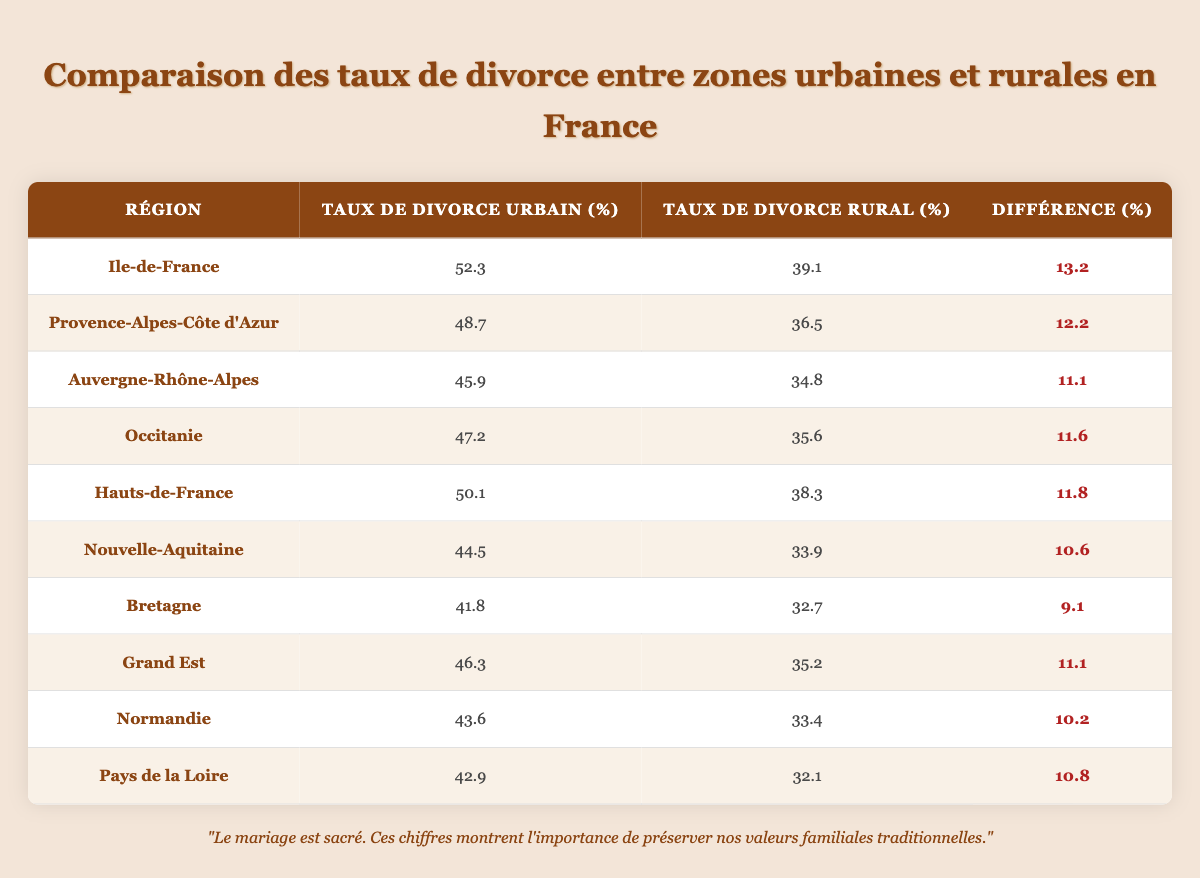What is the urban divorce rate in Ile-de-France? The table lists the urban divorce rate for Ile-de-France as 52.3%.
Answer: 52.3% What is the rural divorce rate in Provence-Alpes-Côte d'Azur? The table shows that the rural divorce rate in Provence-Alpes-Côte d'Azur is 36.5%.
Answer: 36.5% Which region has the highest difference in divorce rates between urban and rural areas? By comparing the "Difference (%)" column, Ile-de-France has the highest difference of 13.2%.
Answer: Ile-de-France Is the rural divorce rate in Nouvelle-Aquitaine higher than that in Bretagne? Looking at the rural rates, Nouvelle-Aquitaine has 33.9% and Bretagne has 32.7%, so Nouvelle-Aquitaine is indeed higher.
Answer: Yes What is the average urban divorce rate across all regions listed? The urban divorce rates are: 52.3, 48.7, 45.9, 47.2, 50.1, 44.5, 41.8, 46.3, 43.6, and 42.9. Summing these gives 460.3, and dividing by 10 gives an average of 46.03%.
Answer: 46.03% How many regions have a rural divorce rate below 35%? By examining the rural rates, Auvergne-Rhône-Alpes (34.8%), Nouvelle-Aquitaine (33.9%), Bretagne (32.7%), and Pays de la Loire (32.1%) are the only ones below 35%. This totals four regions.
Answer: 4 What is the total difference in divorce rates for all regions combined? Adding up all the differences: 13.2 + 12.2 + 11.1 + 11.6 + 11.8 + 10.6 + 9.1 + 11.1 + 10.2 + 10.8 equals 118.7%. Therefore, the total difference is 118.7%.
Answer: 118.7% Is it true that urban divorce rates are generally higher than rural divorce rates in France? Examining the urban and rural rates in each region, all urban rates exceed their corresponding rural rates, confirming that it is true.
Answer: Yes 